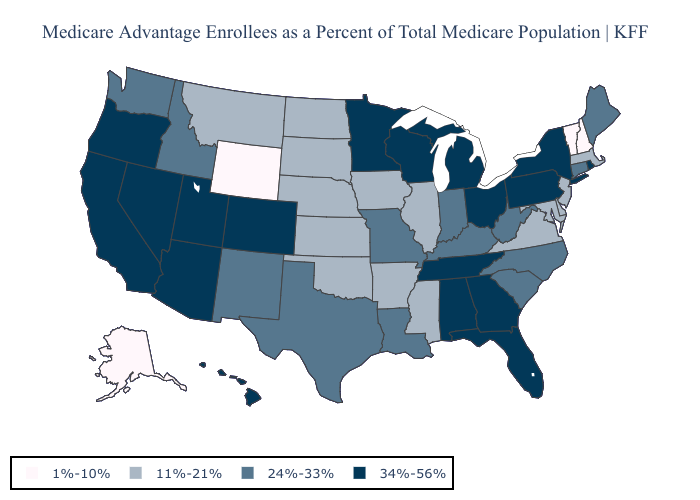What is the value of Colorado?
Answer briefly. 34%-56%. Among the states that border North Carolina , which have the lowest value?
Write a very short answer. Virginia. Does Indiana have the highest value in the USA?
Write a very short answer. No. Which states hav the highest value in the South?
Concise answer only. Alabama, Florida, Georgia, Tennessee. What is the value of Mississippi?
Give a very brief answer. 11%-21%. What is the lowest value in states that border Kansas?
Answer briefly. 11%-21%. What is the value of Georgia?
Quick response, please. 34%-56%. Name the states that have a value in the range 1%-10%?
Concise answer only. Alaska, New Hampshire, Vermont, Wyoming. Name the states that have a value in the range 1%-10%?
Write a very short answer. Alaska, New Hampshire, Vermont, Wyoming. Which states have the lowest value in the West?
Quick response, please. Alaska, Wyoming. Which states have the highest value in the USA?
Keep it brief. Alabama, Arizona, California, Colorado, Florida, Georgia, Hawaii, Michigan, Minnesota, Nevada, New York, Ohio, Oregon, Pennsylvania, Rhode Island, Tennessee, Utah, Wisconsin. Does the first symbol in the legend represent the smallest category?
Give a very brief answer. Yes. Which states hav the highest value in the Northeast?
Be succinct. New York, Pennsylvania, Rhode Island. Does South Carolina have the highest value in the South?
Answer briefly. No. What is the value of Arizona?
Be succinct. 34%-56%. 